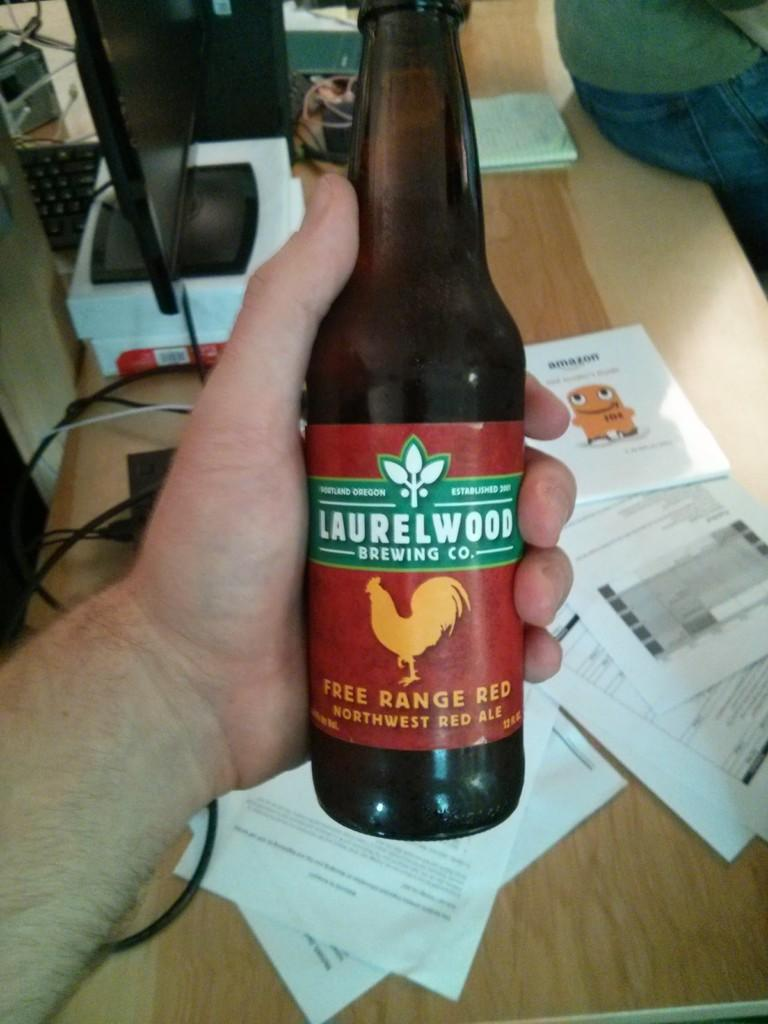<image>
Describe the image concisely. A hand is holding a bottle from Laurelwood Brewing company with a rooster on the label. 